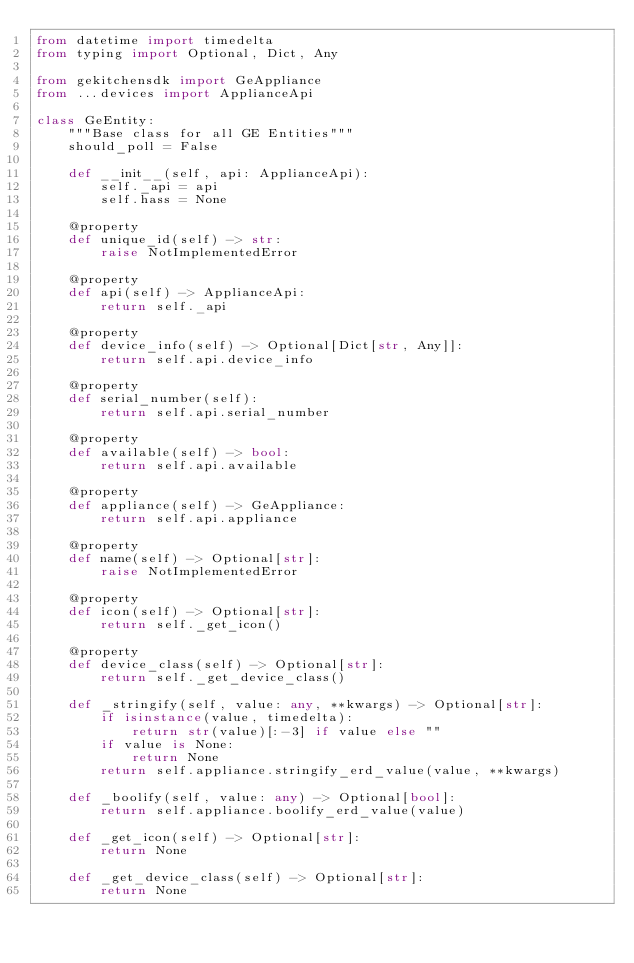<code> <loc_0><loc_0><loc_500><loc_500><_Python_>from datetime import timedelta
from typing import Optional, Dict, Any

from gekitchensdk import GeAppliance
from ...devices import ApplianceApi

class GeEntity:
    """Base class for all GE Entities"""
    should_poll = False

    def __init__(self, api: ApplianceApi):
        self._api = api
        self.hass = None

    @property
    def unique_id(self) -> str:
        raise NotImplementedError

    @property
    def api(self) -> ApplianceApi:
        return self._api

    @property
    def device_info(self) -> Optional[Dict[str, Any]]:
        return self.api.device_info

    @property
    def serial_number(self):
        return self.api.serial_number

    @property
    def available(self) -> bool:
        return self.api.available

    @property
    def appliance(self) -> GeAppliance:
        return self.api.appliance

    @property
    def name(self) -> Optional[str]:
        raise NotImplementedError

    @property
    def icon(self) -> Optional[str]:
        return self._get_icon()

    @property
    def device_class(self) -> Optional[str]:
        return self._get_device_class()    

    def _stringify(self, value: any, **kwargs) -> Optional[str]:
        if isinstance(value, timedelta):
            return str(value)[:-3] if value else ""
        if value is None:
            return None
        return self.appliance.stringify_erd_value(value, **kwargs)

    def _boolify(self, value: any) -> Optional[bool]:
        return self.appliance.boolify_erd_value(value)

    def _get_icon(self) -> Optional[str]:
        return None

    def _get_device_class(self) -> Optional[str]:
        return None</code> 